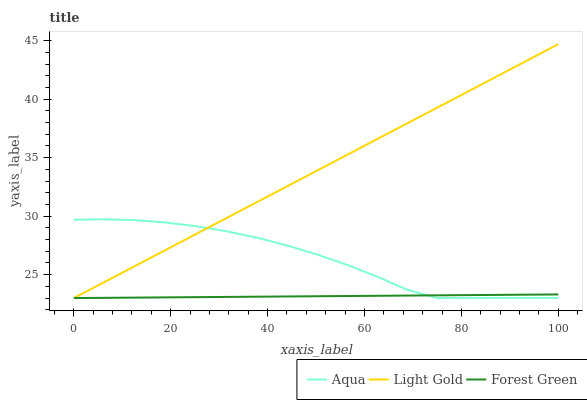Does Forest Green have the minimum area under the curve?
Answer yes or no. Yes. Does Light Gold have the maximum area under the curve?
Answer yes or no. Yes. Does Aqua have the minimum area under the curve?
Answer yes or no. No. Does Aqua have the maximum area under the curve?
Answer yes or no. No. Is Forest Green the smoothest?
Answer yes or no. Yes. Is Aqua the roughest?
Answer yes or no. Yes. Is Aqua the smoothest?
Answer yes or no. No. Is Forest Green the roughest?
Answer yes or no. No. Does Aqua have the highest value?
Answer yes or no. No. 